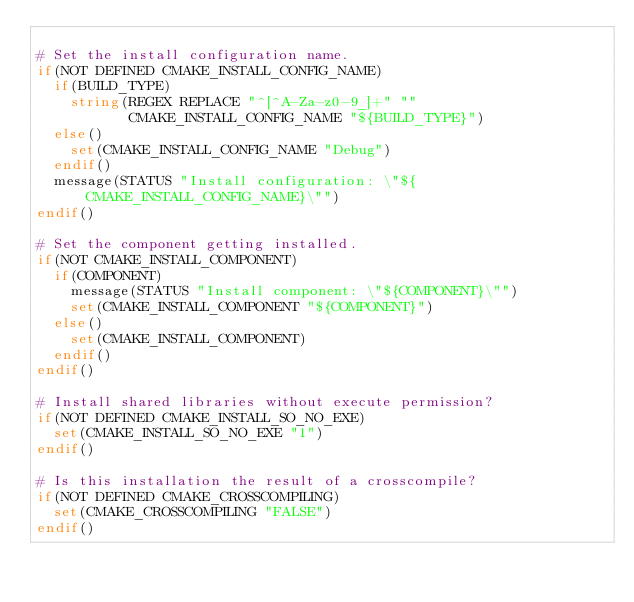Convert code to text. <code><loc_0><loc_0><loc_500><loc_500><_CMake_>
# Set the install configuration name.
if(NOT DEFINED CMAKE_INSTALL_CONFIG_NAME)
  if(BUILD_TYPE)
    string(REGEX REPLACE "^[^A-Za-z0-9_]+" ""
           CMAKE_INSTALL_CONFIG_NAME "${BUILD_TYPE}")
  else()
    set(CMAKE_INSTALL_CONFIG_NAME "Debug")
  endif()
  message(STATUS "Install configuration: \"${CMAKE_INSTALL_CONFIG_NAME}\"")
endif()

# Set the component getting installed.
if(NOT CMAKE_INSTALL_COMPONENT)
  if(COMPONENT)
    message(STATUS "Install component: \"${COMPONENT}\"")
    set(CMAKE_INSTALL_COMPONENT "${COMPONENT}")
  else()
    set(CMAKE_INSTALL_COMPONENT)
  endif()
endif()

# Install shared libraries without execute permission?
if(NOT DEFINED CMAKE_INSTALL_SO_NO_EXE)
  set(CMAKE_INSTALL_SO_NO_EXE "1")
endif()

# Is this installation the result of a crosscompile?
if(NOT DEFINED CMAKE_CROSSCOMPILING)
  set(CMAKE_CROSSCOMPILING "FALSE")
endif()

</code> 